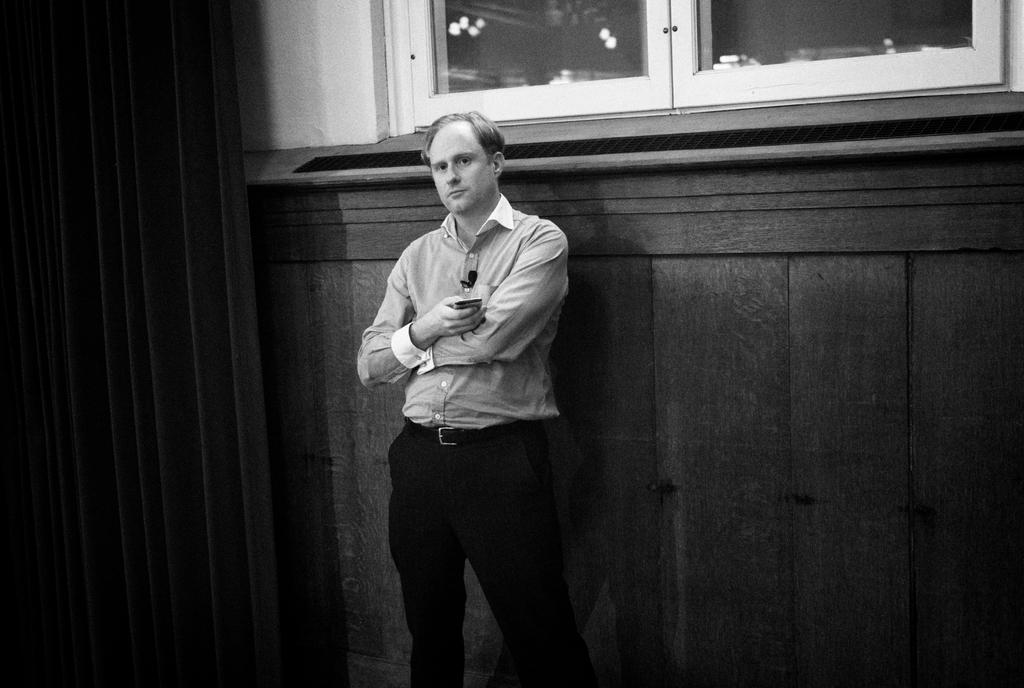What is the main subject of the image? There is a man standing in the middle of the image. What is the man holding in the image? The man is holding glasses. What can be seen behind the man in the image? There is a wall behind the man. What type of clover is the man holding in the image? There is no clover present in the image; the man is holding glasses. 